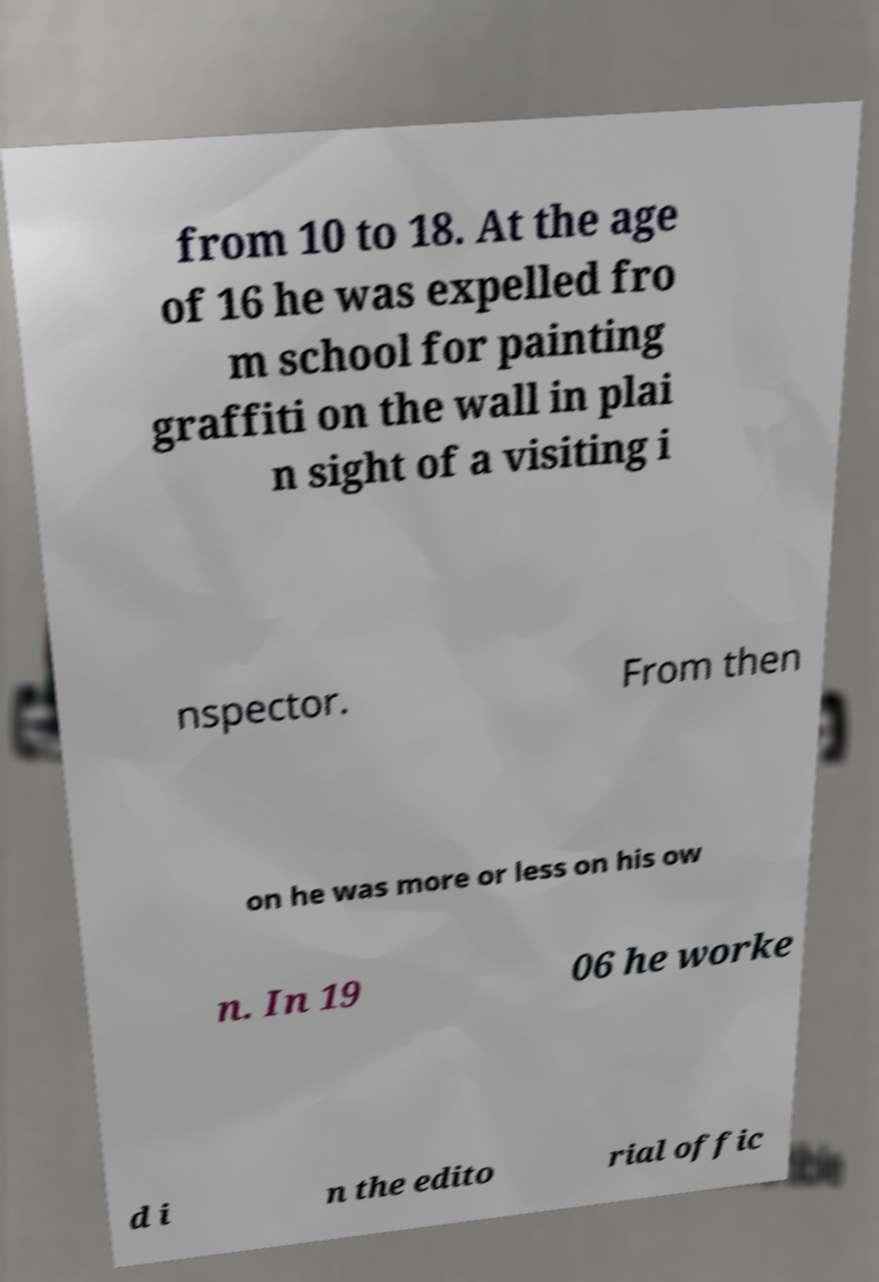I need the written content from this picture converted into text. Can you do that? from 10 to 18. At the age of 16 he was expelled fro m school for painting graffiti on the wall in plai n sight of a visiting i nspector. From then on he was more or less on his ow n. In 19 06 he worke d i n the edito rial offic 